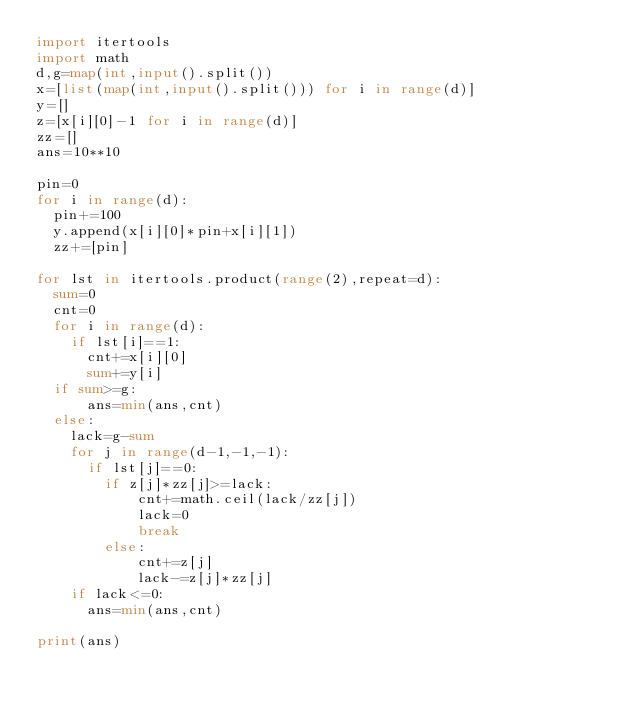<code> <loc_0><loc_0><loc_500><loc_500><_Python_>import itertools
import math
d,g=map(int,input().split())
x=[list(map(int,input().split())) for i in range(d)]
y=[]
z=[x[i][0]-1 for i in range(d)]
zz=[]
ans=10**10

pin=0
for i in range(d):
  pin+=100
  y.append(x[i][0]*pin+x[i][1])
  zz+=[pin]

for lst in itertools.product(range(2),repeat=d):
  sum=0
  cnt=0
  for i in range(d):
    if lst[i]==1:
      cnt+=x[i][0]
      sum+=y[i]
  if sum>=g:
      ans=min(ans,cnt)
  else:
    lack=g-sum
    for j in range(d-1,-1,-1):
      if lst[j]==0:  
        if z[j]*zz[j]>=lack:
            cnt+=math.ceil(lack/zz[j])
            lack=0
            break
        else:
            cnt+=z[j]
            lack-=z[j]*zz[j]
    if lack<=0:
      ans=min(ans,cnt)

print(ans)</code> 